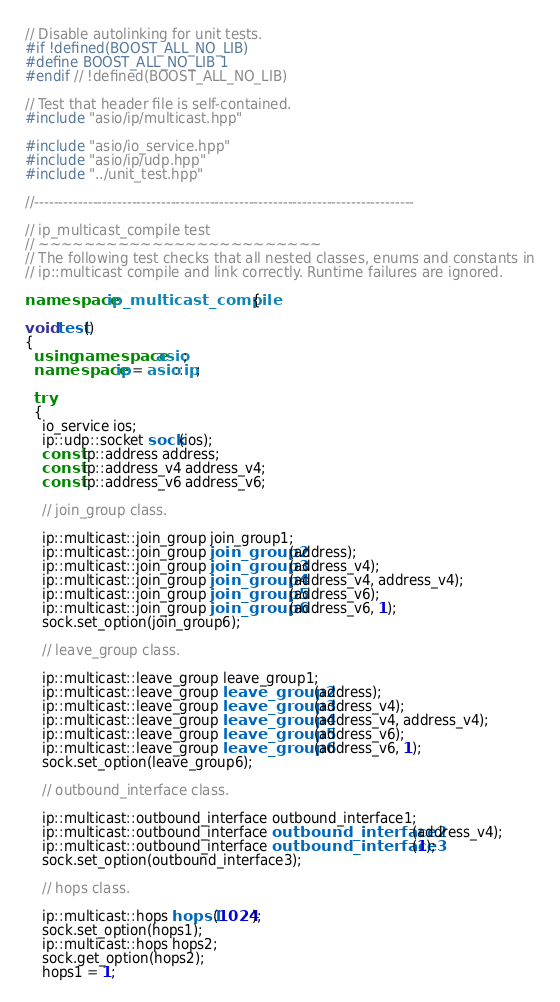Convert code to text. <code><loc_0><loc_0><loc_500><loc_500><_C++_>// Disable autolinking for unit tests.
#if !defined(BOOST_ALL_NO_LIB)
#define BOOST_ALL_NO_LIB 1
#endif // !defined(BOOST_ALL_NO_LIB)

// Test that header file is self-contained.
#include "asio/ip/multicast.hpp"

#include "asio/io_service.hpp"
#include "asio/ip/udp.hpp"
#include "../unit_test.hpp"

//------------------------------------------------------------------------------

// ip_multicast_compile test
// ~~~~~~~~~~~~~~~~~~~~~~~~~
// The following test checks that all nested classes, enums and constants in
// ip::multicast compile and link correctly. Runtime failures are ignored.

namespace ip_multicast_compile {

void test()
{
  using namespace asio;
  namespace ip = asio::ip;

  try
  {
    io_service ios;
    ip::udp::socket sock(ios);
    const ip::address address;
    const ip::address_v4 address_v4;
    const ip::address_v6 address_v6;

    // join_group class.

    ip::multicast::join_group join_group1;
    ip::multicast::join_group join_group2(address);
    ip::multicast::join_group join_group3(address_v4);
    ip::multicast::join_group join_group4(address_v4, address_v4);
    ip::multicast::join_group join_group5(address_v6);
    ip::multicast::join_group join_group6(address_v6, 1);
    sock.set_option(join_group6);

    // leave_group class.

    ip::multicast::leave_group leave_group1;
    ip::multicast::leave_group leave_group2(address);
    ip::multicast::leave_group leave_group3(address_v4);
    ip::multicast::leave_group leave_group4(address_v4, address_v4);
    ip::multicast::leave_group leave_group5(address_v6);
    ip::multicast::leave_group leave_group6(address_v6, 1);
    sock.set_option(leave_group6);

    // outbound_interface class.

    ip::multicast::outbound_interface outbound_interface1;
    ip::multicast::outbound_interface outbound_interface2(address_v4);
    ip::multicast::outbound_interface outbound_interface3(1);
    sock.set_option(outbound_interface3);

    // hops class.

    ip::multicast::hops hops1(1024);
    sock.set_option(hops1);
    ip::multicast::hops hops2;
    sock.get_option(hops2);
    hops1 = 1;</code> 